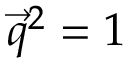Convert formula to latex. <formula><loc_0><loc_0><loc_500><loc_500>\begin{array} { r } { \vec { q } ^ { 2 } = 1 } \end{array}</formula> 